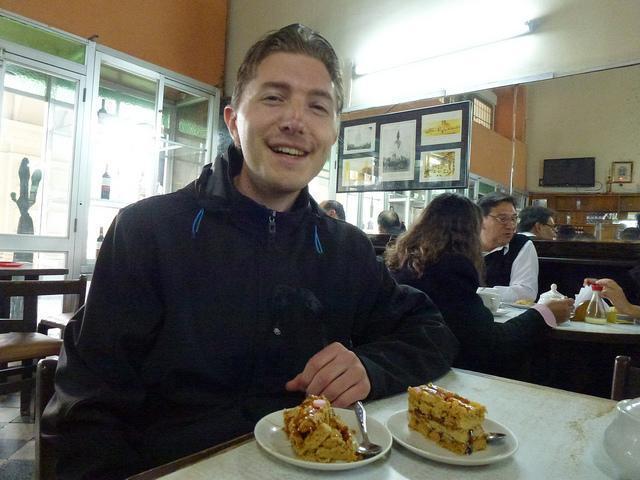What type food is this man enjoying?
From the following four choices, select the correct answer to address the question.
Options: Pizza, soup, dessert food, salad. Dessert food. 